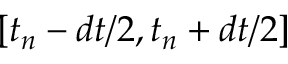<formula> <loc_0><loc_0><loc_500><loc_500>[ t _ { n } - d t / 2 , t _ { n } + d t / 2 ]</formula> 